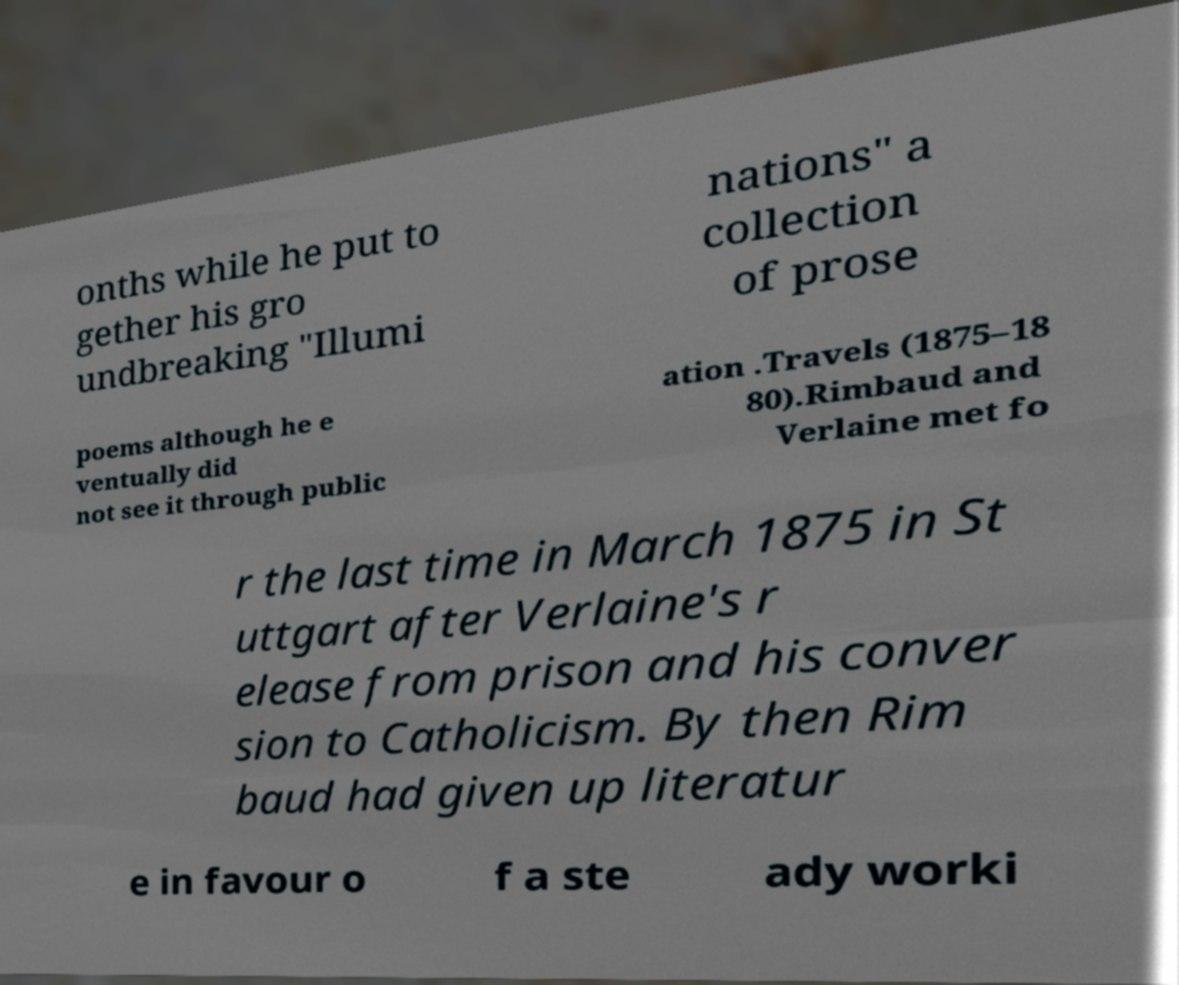Could you assist in decoding the text presented in this image and type it out clearly? onths while he put to gether his gro undbreaking "Illumi nations" a collection of prose poems although he e ventually did not see it through public ation .Travels (1875–18 80).Rimbaud and Verlaine met fo r the last time in March 1875 in St uttgart after Verlaine's r elease from prison and his conver sion to Catholicism. By then Rim baud had given up literatur e in favour o f a ste ady worki 